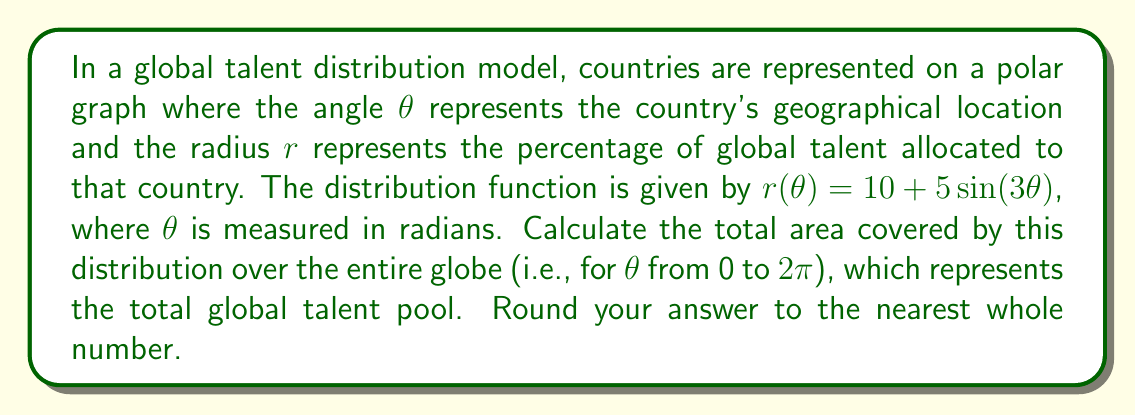Help me with this question. To solve this problem, we need to calculate the area enclosed by the polar curve $r(\theta) = 10 + 5\sin(3\theta)$ over the interval $[0, 2\pi]$. We can use the formula for the area of a region bounded by a polar curve:

$$A = \frac{1}{2} \int_{0}^{2\pi} [r(\theta)]^2 d\theta$$

Let's break this down step-by-step:

1) First, we square the given function:
   $$[r(\theta)]^2 = (10 + 5\sin(3\theta))^2 = 100 + 100\sin(3\theta) + 25\sin^2(3\theta)$$

2) Now we integrate this function from 0 to $2\pi$:
   $$A = \frac{1}{2} \int_{0}^{2\pi} (100 + 100\sin(3\theta) + 25\sin^2(3\theta)) d\theta$$

3) Let's integrate each term separately:
   
   a) $\int_{0}^{2\pi} 100 d\theta = 100\theta |_{0}^{2\pi} = 200\pi$
   
   b) $\int_{0}^{2\pi} 100\sin(3\theta) d\theta = -\frac{100}{3}\cos(3\theta) |_{0}^{2\pi} = 0$
   
   c) For the $\sin^2$ term, we can use the identity $\sin^2x = \frac{1-\cos(2x)}{2}$:
      $$\int_{0}^{2\pi} 25\sin^2(3\theta) d\theta = \int_{0}^{2\pi} \frac{25}{2}(1-\cos(6\theta)) d\theta$$
      $$= \frac{25}{2}\theta - \frac{25}{12}\sin(6\theta) |_{0}^{2\pi} = 25\pi$$

4) Adding these results:
   $$A = \frac{1}{2}(200\pi + 0 + 25\pi) = \frac{225\pi}{2} \approx 353.4$$

5) Rounding to the nearest whole number:
   $$A \approx 353$$

This area represents the total global talent pool distributed across all countries.
Answer: 353 